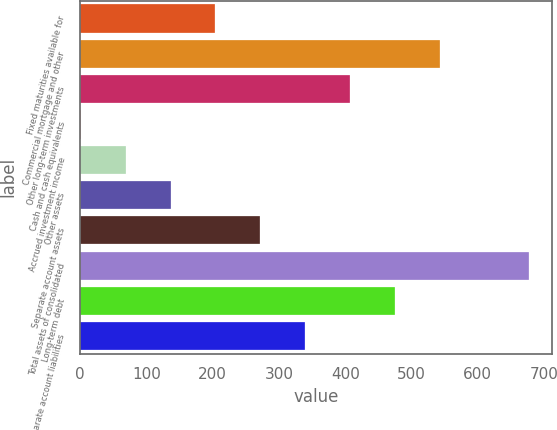<chart> <loc_0><loc_0><loc_500><loc_500><bar_chart><fcel>Fixed maturities available for<fcel>Commercial mortgage and other<fcel>Other long-term investments<fcel>Cash and cash equivalents<fcel>Accrued investment income<fcel>Other assets<fcel>Separate account assets<fcel>Total assets of consolidated<fcel>Long-term debt<fcel>Separate account liabilities<nl><fcel>204.1<fcel>542.6<fcel>407.2<fcel>1<fcel>68.7<fcel>136.4<fcel>271.8<fcel>678<fcel>474.9<fcel>339.5<nl></chart> 